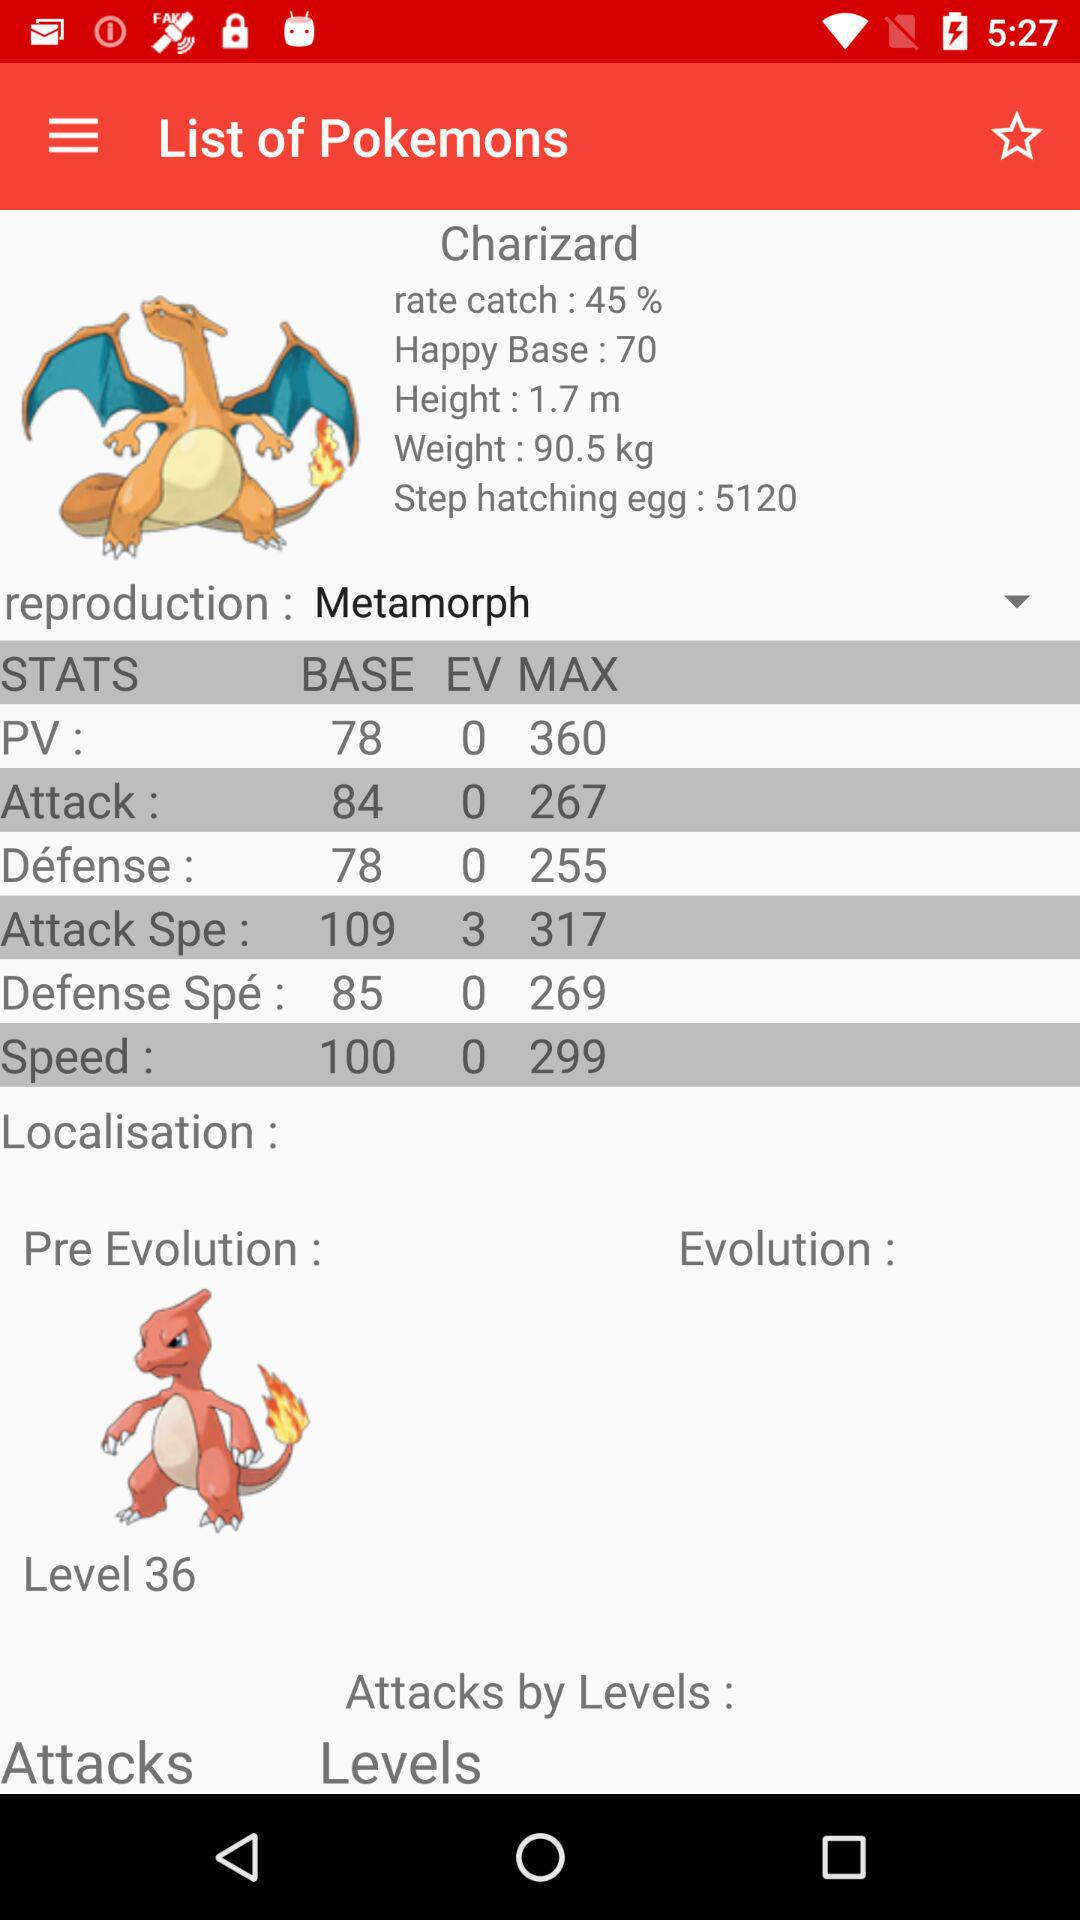What is the height? The height is 1.7 meters. 